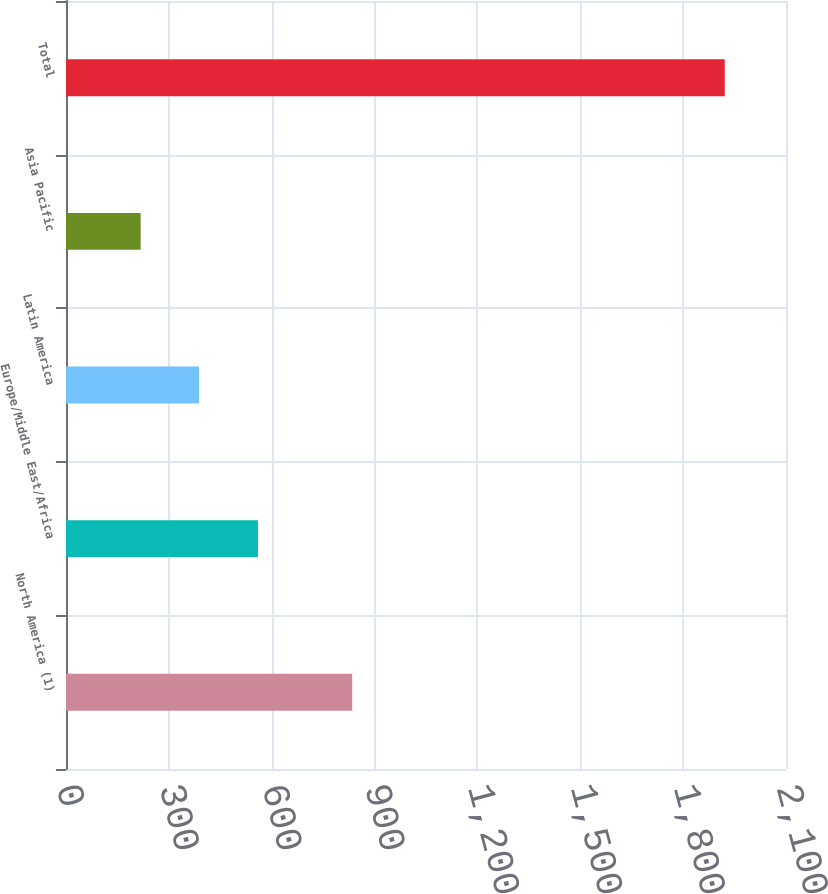Convert chart. <chart><loc_0><loc_0><loc_500><loc_500><bar_chart><fcel>North America (1)<fcel>Europe/Middle East/Africa<fcel>Latin America<fcel>Asia Pacific<fcel>Total<nl><fcel>834.8<fcel>559.9<fcel>388.16<fcel>217.8<fcel>1921.4<nl></chart> 